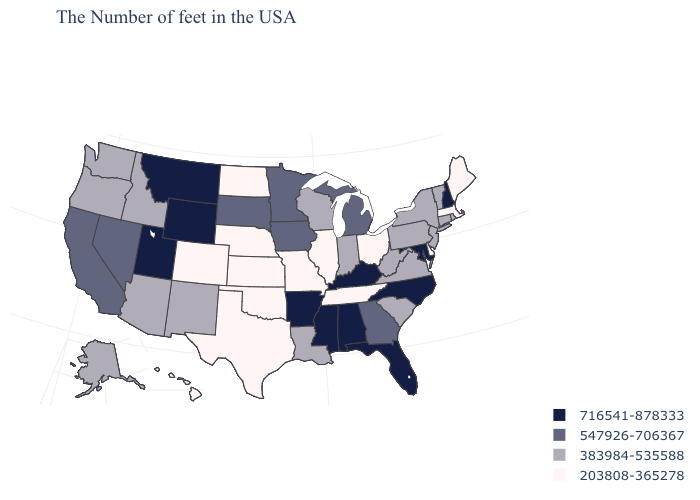Name the states that have a value in the range 203808-365278?
Quick response, please. Maine, Massachusetts, Delaware, Ohio, Tennessee, Illinois, Missouri, Kansas, Nebraska, Oklahoma, Texas, North Dakota, Colorado, Hawaii. What is the value of Mississippi?
Keep it brief. 716541-878333. Does Florida have a higher value than Kansas?
Give a very brief answer. Yes. Is the legend a continuous bar?
Keep it brief. No. What is the lowest value in states that border North Dakota?
Be succinct. 547926-706367. What is the value of Arizona?
Give a very brief answer. 383984-535588. Does Massachusetts have the highest value in the Northeast?
Write a very short answer. No. What is the value of Vermont?
Answer briefly. 383984-535588. Name the states that have a value in the range 547926-706367?
Answer briefly. Georgia, Michigan, Minnesota, Iowa, South Dakota, Nevada, California. Name the states that have a value in the range 203808-365278?
Keep it brief. Maine, Massachusetts, Delaware, Ohio, Tennessee, Illinois, Missouri, Kansas, Nebraska, Oklahoma, Texas, North Dakota, Colorado, Hawaii. Among the states that border Iowa , which have the lowest value?
Write a very short answer. Illinois, Missouri, Nebraska. Does Kansas have the lowest value in the USA?
Answer briefly. Yes. Name the states that have a value in the range 203808-365278?
Be succinct. Maine, Massachusetts, Delaware, Ohio, Tennessee, Illinois, Missouri, Kansas, Nebraska, Oklahoma, Texas, North Dakota, Colorado, Hawaii. Among the states that border Montana , does North Dakota have the lowest value?
Answer briefly. Yes. Name the states that have a value in the range 547926-706367?
Concise answer only. Georgia, Michigan, Minnesota, Iowa, South Dakota, Nevada, California. 